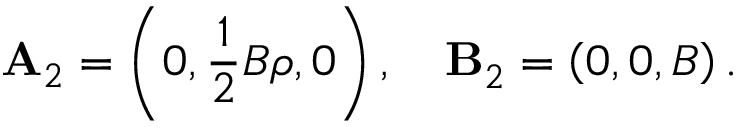Convert formula to latex. <formula><loc_0><loc_0><loc_500><loc_500>A _ { 2 } = \left ( 0 , \frac { 1 } { 2 } B \rho , 0 \right ) , \ B _ { 2 } = \left ( 0 , 0 , B \right ) .</formula> 